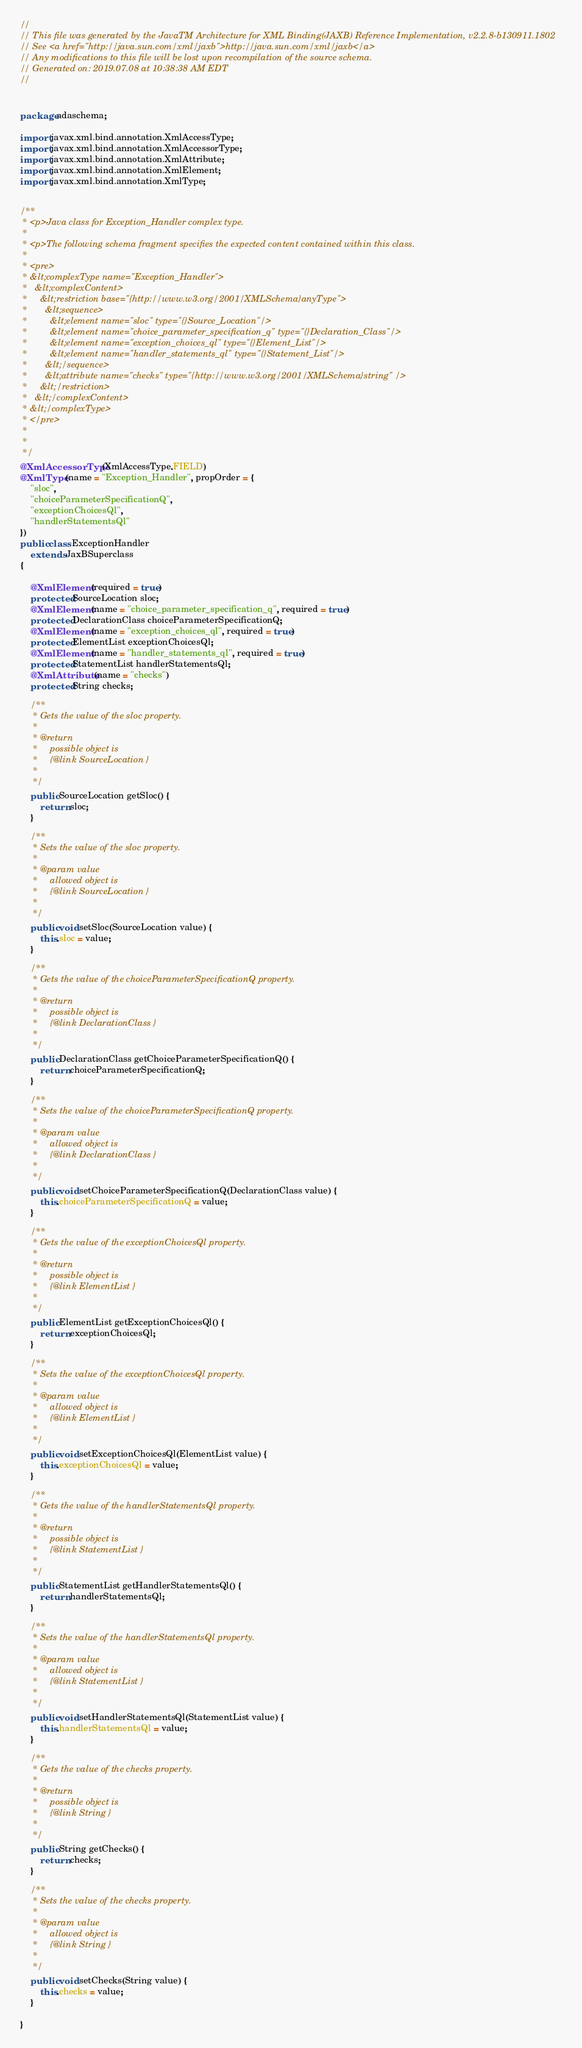<code> <loc_0><loc_0><loc_500><loc_500><_Java_>//
// This file was generated by the JavaTM Architecture for XML Binding(JAXB) Reference Implementation, v2.2.8-b130911.1802 
// See <a href="http://java.sun.com/xml/jaxb">http://java.sun.com/xml/jaxb</a> 
// Any modifications to this file will be lost upon recompilation of the source schema. 
// Generated on: 2019.07.08 at 10:38:38 AM EDT 
//


package adaschema;

import javax.xml.bind.annotation.XmlAccessType;
import javax.xml.bind.annotation.XmlAccessorType;
import javax.xml.bind.annotation.XmlAttribute;
import javax.xml.bind.annotation.XmlElement;
import javax.xml.bind.annotation.XmlType;


/**
 * <p>Java class for Exception_Handler complex type.
 * 
 * <p>The following schema fragment specifies the expected content contained within this class.
 * 
 * <pre>
 * &lt;complexType name="Exception_Handler">
 *   &lt;complexContent>
 *     &lt;restriction base="{http://www.w3.org/2001/XMLSchema}anyType">
 *       &lt;sequence>
 *         &lt;element name="sloc" type="{}Source_Location"/>
 *         &lt;element name="choice_parameter_specification_q" type="{}Declaration_Class"/>
 *         &lt;element name="exception_choices_ql" type="{}Element_List"/>
 *         &lt;element name="handler_statements_ql" type="{}Statement_List"/>
 *       &lt;/sequence>
 *       &lt;attribute name="checks" type="{http://www.w3.org/2001/XMLSchema}string" />
 *     &lt;/restriction>
 *   &lt;/complexContent>
 * &lt;/complexType>
 * </pre>
 * 
 * 
 */
@XmlAccessorType(XmlAccessType.FIELD)
@XmlType(name = "Exception_Handler", propOrder = {
    "sloc",
    "choiceParameterSpecificationQ",
    "exceptionChoicesQl",
    "handlerStatementsQl"
})
public class ExceptionHandler
    extends JaxBSuperclass
{

    @XmlElement(required = true)
    protected SourceLocation sloc;
    @XmlElement(name = "choice_parameter_specification_q", required = true)
    protected DeclarationClass choiceParameterSpecificationQ;
    @XmlElement(name = "exception_choices_ql", required = true)
    protected ElementList exceptionChoicesQl;
    @XmlElement(name = "handler_statements_ql", required = true)
    protected StatementList handlerStatementsQl;
    @XmlAttribute(name = "checks")
    protected String checks;

    /**
     * Gets the value of the sloc property.
     * 
     * @return
     *     possible object is
     *     {@link SourceLocation }
     *     
     */
    public SourceLocation getSloc() {
        return sloc;
    }

    /**
     * Sets the value of the sloc property.
     * 
     * @param value
     *     allowed object is
     *     {@link SourceLocation }
     *     
     */
    public void setSloc(SourceLocation value) {
        this.sloc = value;
    }

    /**
     * Gets the value of the choiceParameterSpecificationQ property.
     * 
     * @return
     *     possible object is
     *     {@link DeclarationClass }
     *     
     */
    public DeclarationClass getChoiceParameterSpecificationQ() {
        return choiceParameterSpecificationQ;
    }

    /**
     * Sets the value of the choiceParameterSpecificationQ property.
     * 
     * @param value
     *     allowed object is
     *     {@link DeclarationClass }
     *     
     */
    public void setChoiceParameterSpecificationQ(DeclarationClass value) {
        this.choiceParameterSpecificationQ = value;
    }

    /**
     * Gets the value of the exceptionChoicesQl property.
     * 
     * @return
     *     possible object is
     *     {@link ElementList }
     *     
     */
    public ElementList getExceptionChoicesQl() {
        return exceptionChoicesQl;
    }

    /**
     * Sets the value of the exceptionChoicesQl property.
     * 
     * @param value
     *     allowed object is
     *     {@link ElementList }
     *     
     */
    public void setExceptionChoicesQl(ElementList value) {
        this.exceptionChoicesQl = value;
    }

    /**
     * Gets the value of the handlerStatementsQl property.
     * 
     * @return
     *     possible object is
     *     {@link StatementList }
     *     
     */
    public StatementList getHandlerStatementsQl() {
        return handlerStatementsQl;
    }

    /**
     * Sets the value of the handlerStatementsQl property.
     * 
     * @param value
     *     allowed object is
     *     {@link StatementList }
     *     
     */
    public void setHandlerStatementsQl(StatementList value) {
        this.handlerStatementsQl = value;
    }

    /**
     * Gets the value of the checks property.
     * 
     * @return
     *     possible object is
     *     {@link String }
     *     
     */
    public String getChecks() {
        return checks;
    }

    /**
     * Sets the value of the checks property.
     * 
     * @param value
     *     allowed object is
     *     {@link String }
     *     
     */
    public void setChecks(String value) {
        this.checks = value;
    }

}
</code> 